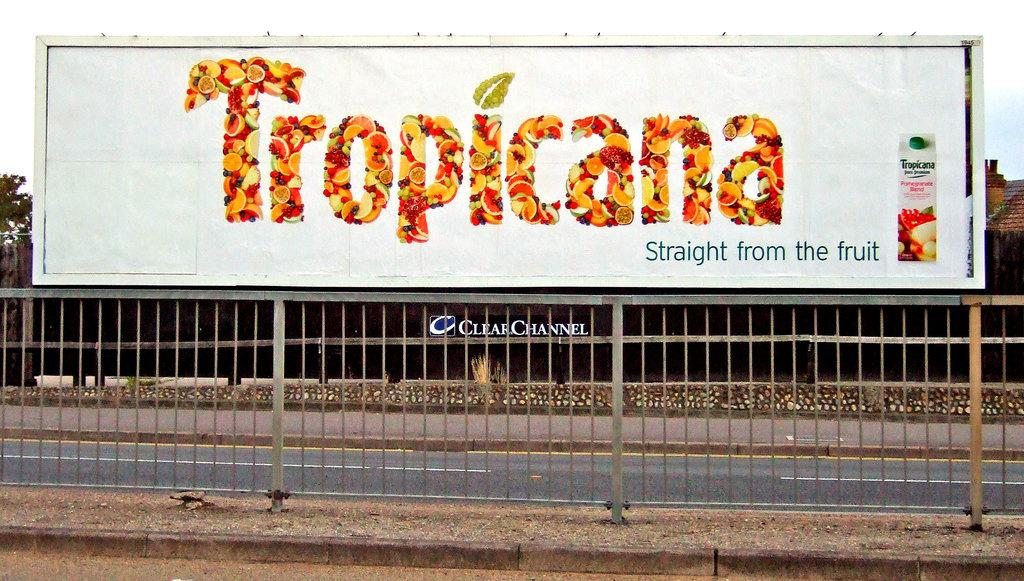<image>
Give a short and clear explanation of the subsequent image. The logo "straight from the fruit" describes the product on the sign. 